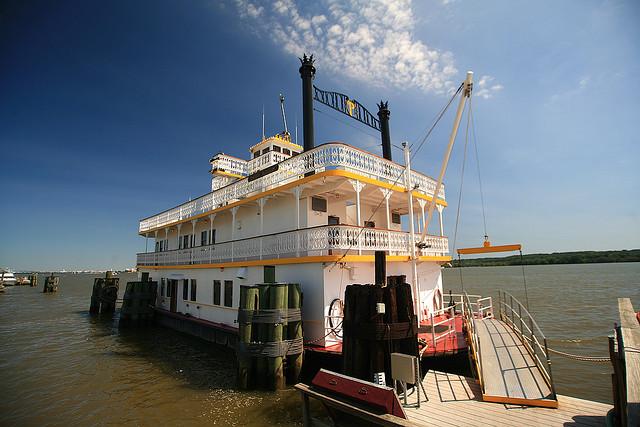What type of boat is docked?
Quick response, please. Ferry. Is it raining?
Write a very short answer. No. How many stories is the boat?
Give a very brief answer. 2. 